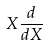Convert formula to latex. <formula><loc_0><loc_0><loc_500><loc_500>X \frac { d } { d X }</formula> 